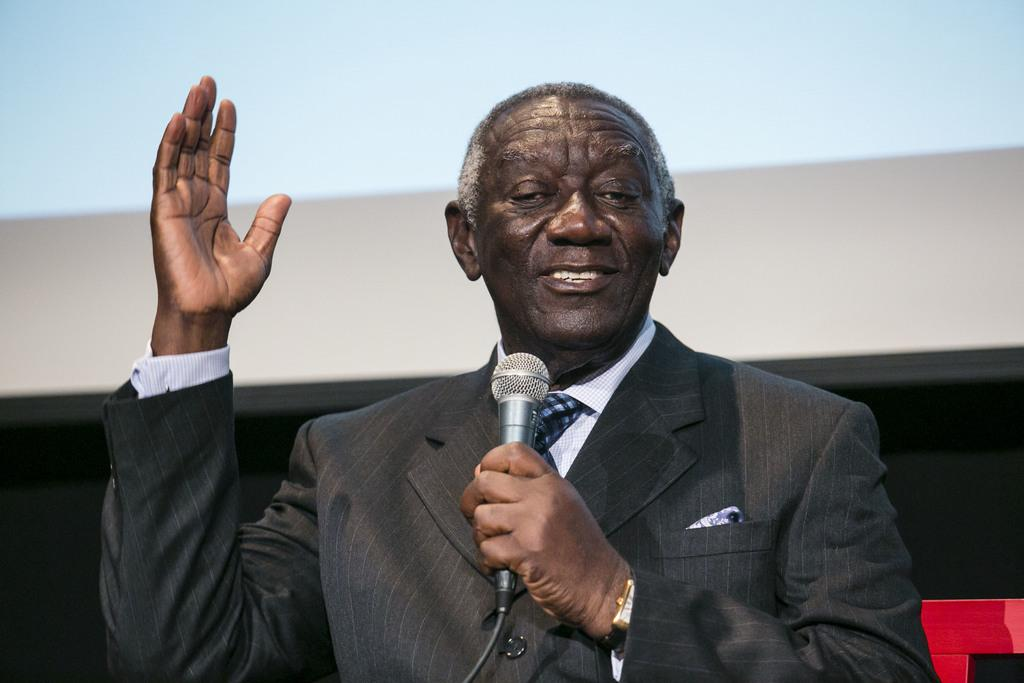Who is the main subject in the image? There is a man in the image. What is the man doing in the image? The man is talking on a microphone. What is the man wearing in the image? The man is wearing a suit. What can be seen in the background of the image? There is a screen in the background of the image. What type of pin is the man wearing on his lapel in the image? There is no pin visible on the man's suit in the image. What type of voyage is the man embarking on after his speech in the image? There is no indication of a voyage or any travel plans in the image; the man is simply talking on a microphone. 